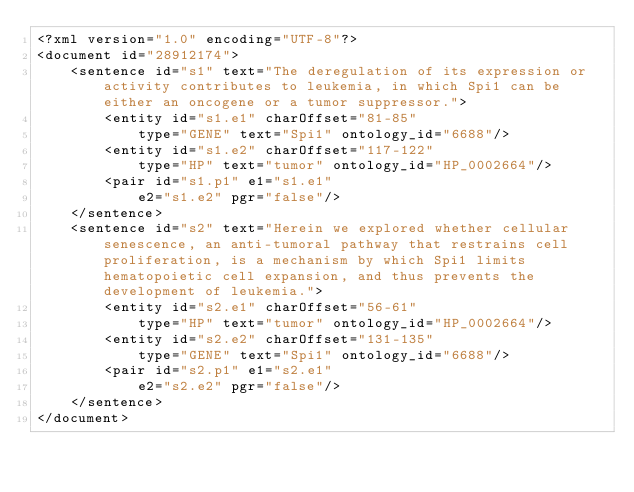Convert code to text. <code><loc_0><loc_0><loc_500><loc_500><_XML_><?xml version="1.0" encoding="UTF-8"?>
<document id="28912174">
	<sentence id="s1" text="The deregulation of its expression or activity contributes to leukemia, in which Spi1 can be either an oncogene or a tumor suppressor.">
		<entity id="s1.e1" charOffset="81-85"
			type="GENE" text="Spi1" ontology_id="6688"/>
		<entity id="s1.e2" charOffset="117-122"
			type="HP" text="tumor" ontology_id="HP_0002664"/>
		<pair id="s1.p1" e1="s1.e1"
		    e2="s1.e2" pgr="false"/>
	</sentence>
	<sentence id="s2" text="Herein we explored whether cellular senescence, an anti-tumoral pathway that restrains cell proliferation, is a mechanism by which Spi1 limits hematopoietic cell expansion, and thus prevents the development of leukemia.">
		<entity id="s2.e1" charOffset="56-61"
			type="HP" text="tumor" ontology_id="HP_0002664"/>
		<entity id="s2.e2" charOffset="131-135"
			type="GENE" text="Spi1" ontology_id="6688"/>
		<pair id="s2.p1" e1="s2.e1"
		    e2="s2.e2" pgr="false"/>
	</sentence>
</document>
</code> 